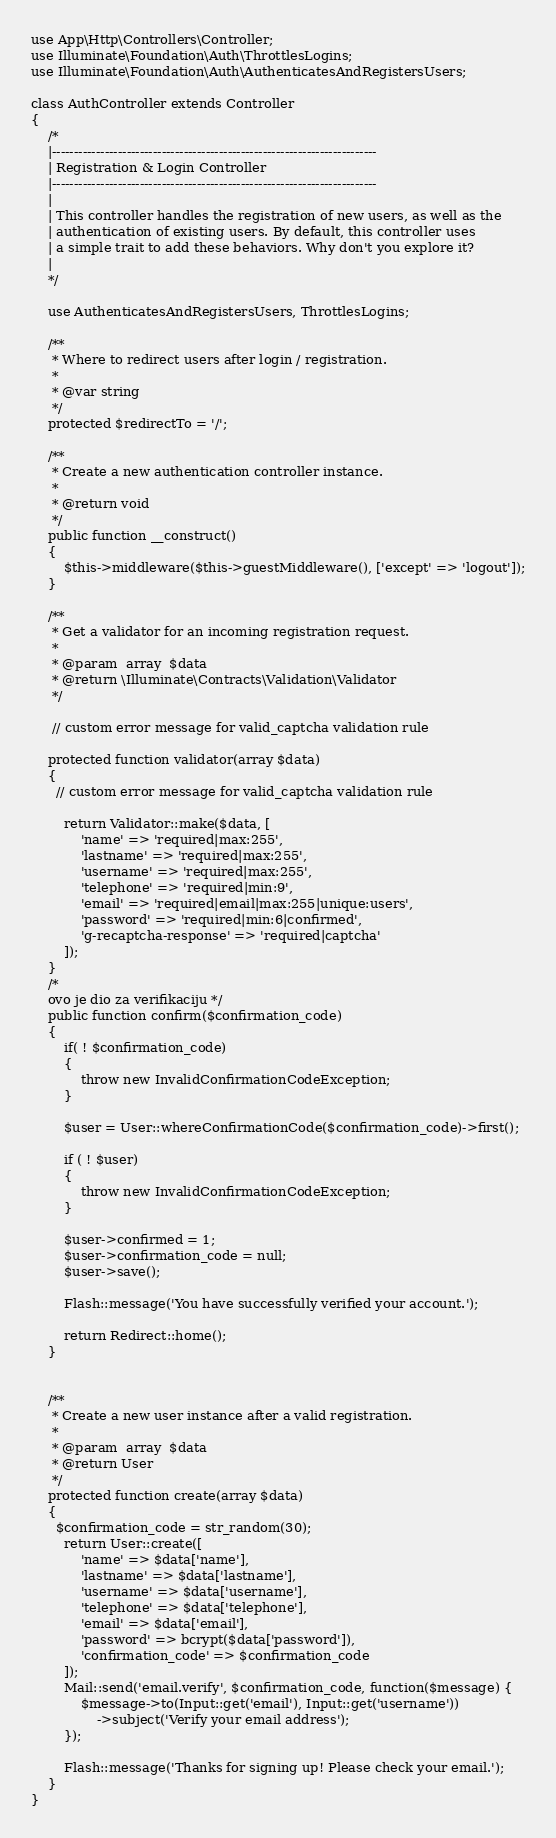<code> <loc_0><loc_0><loc_500><loc_500><_PHP_>use App\Http\Controllers\Controller;
use Illuminate\Foundation\Auth\ThrottlesLogins;
use Illuminate\Foundation\Auth\AuthenticatesAndRegistersUsers;

class AuthController extends Controller
{
    /*
    |--------------------------------------------------------------------------
    | Registration & Login Controller
    |--------------------------------------------------------------------------
    |
    | This controller handles the registration of new users, as well as the
    | authentication of existing users. By default, this controller uses
    | a simple trait to add these behaviors. Why don't you explore it?
    |
    */

    use AuthenticatesAndRegistersUsers, ThrottlesLogins;

    /**
     * Where to redirect users after login / registration.
     *
     * @var string
     */
    protected $redirectTo = '/';

    /**
     * Create a new authentication controller instance.
     *
     * @return void
     */
    public function __construct()
    {
        $this->middleware($this->guestMiddleware(), ['except' => 'logout']);
    }

    /**
     * Get a validator for an incoming registration request.
     *
     * @param  array  $data
     * @return \Illuminate\Contracts\Validation\Validator
     */

     // custom error message for valid_captcha validation rule

    protected function validator(array $data)
    {
      // custom error message for valid_captcha validation rule

        return Validator::make($data, [
            'name' => 'required|max:255',
            'lastname' => 'required|max:255',
            'username' => 'required|max:255',
            'telephone' => 'required|min:9',
            'email' => 'required|email|max:255|unique:users',
            'password' => 'required|min:6|confirmed',
            'g-recaptcha-response' => 'required|captcha'
        ]);
    }
    /*
    ovo je dio za verifikaciju */
    public function confirm($confirmation_code)
    {
        if( ! $confirmation_code)
        {
            throw new InvalidConfirmationCodeException;
        }

        $user = User::whereConfirmationCode($confirmation_code)->first();

        if ( ! $user)
        {
            throw new InvalidConfirmationCodeException;
        }

        $user->confirmed = 1;
        $user->confirmation_code = null;
        $user->save();

        Flash::message('You have successfully verified your account.');

        return Redirect::home();
    }


    /**
     * Create a new user instance after a valid registration.
     *
     * @param  array  $data
     * @return User
     */
    protected function create(array $data)
    {
      $confirmation_code = str_random(30);
        return User::create([
            'name' => $data['name'],
            'lastname' => $data['lastname'],
            'username' => $data['username'],
            'telephone' => $data['telephone'],
            'email' => $data['email'],
            'password' => bcrypt($data['password']),
            'confirmation_code' => $confirmation_code
        ]);
        Mail::send('email.verify', $confirmation_code, function($message) {
            $message->to(Input::get('email'), Input::get('username'))
                ->subject('Verify your email address');
        });

        Flash::message('Thanks for signing up! Please check your email.');
    }
}
</code> 